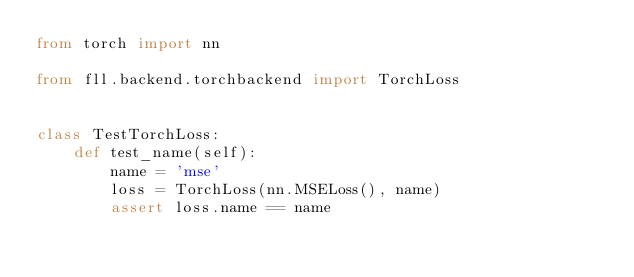<code> <loc_0><loc_0><loc_500><loc_500><_Python_>from torch import nn

from fll.backend.torchbackend import TorchLoss


class TestTorchLoss:
    def test_name(self):
        name = 'mse'
        loss = TorchLoss(nn.MSELoss(), name)
        assert loss.name == name
</code> 